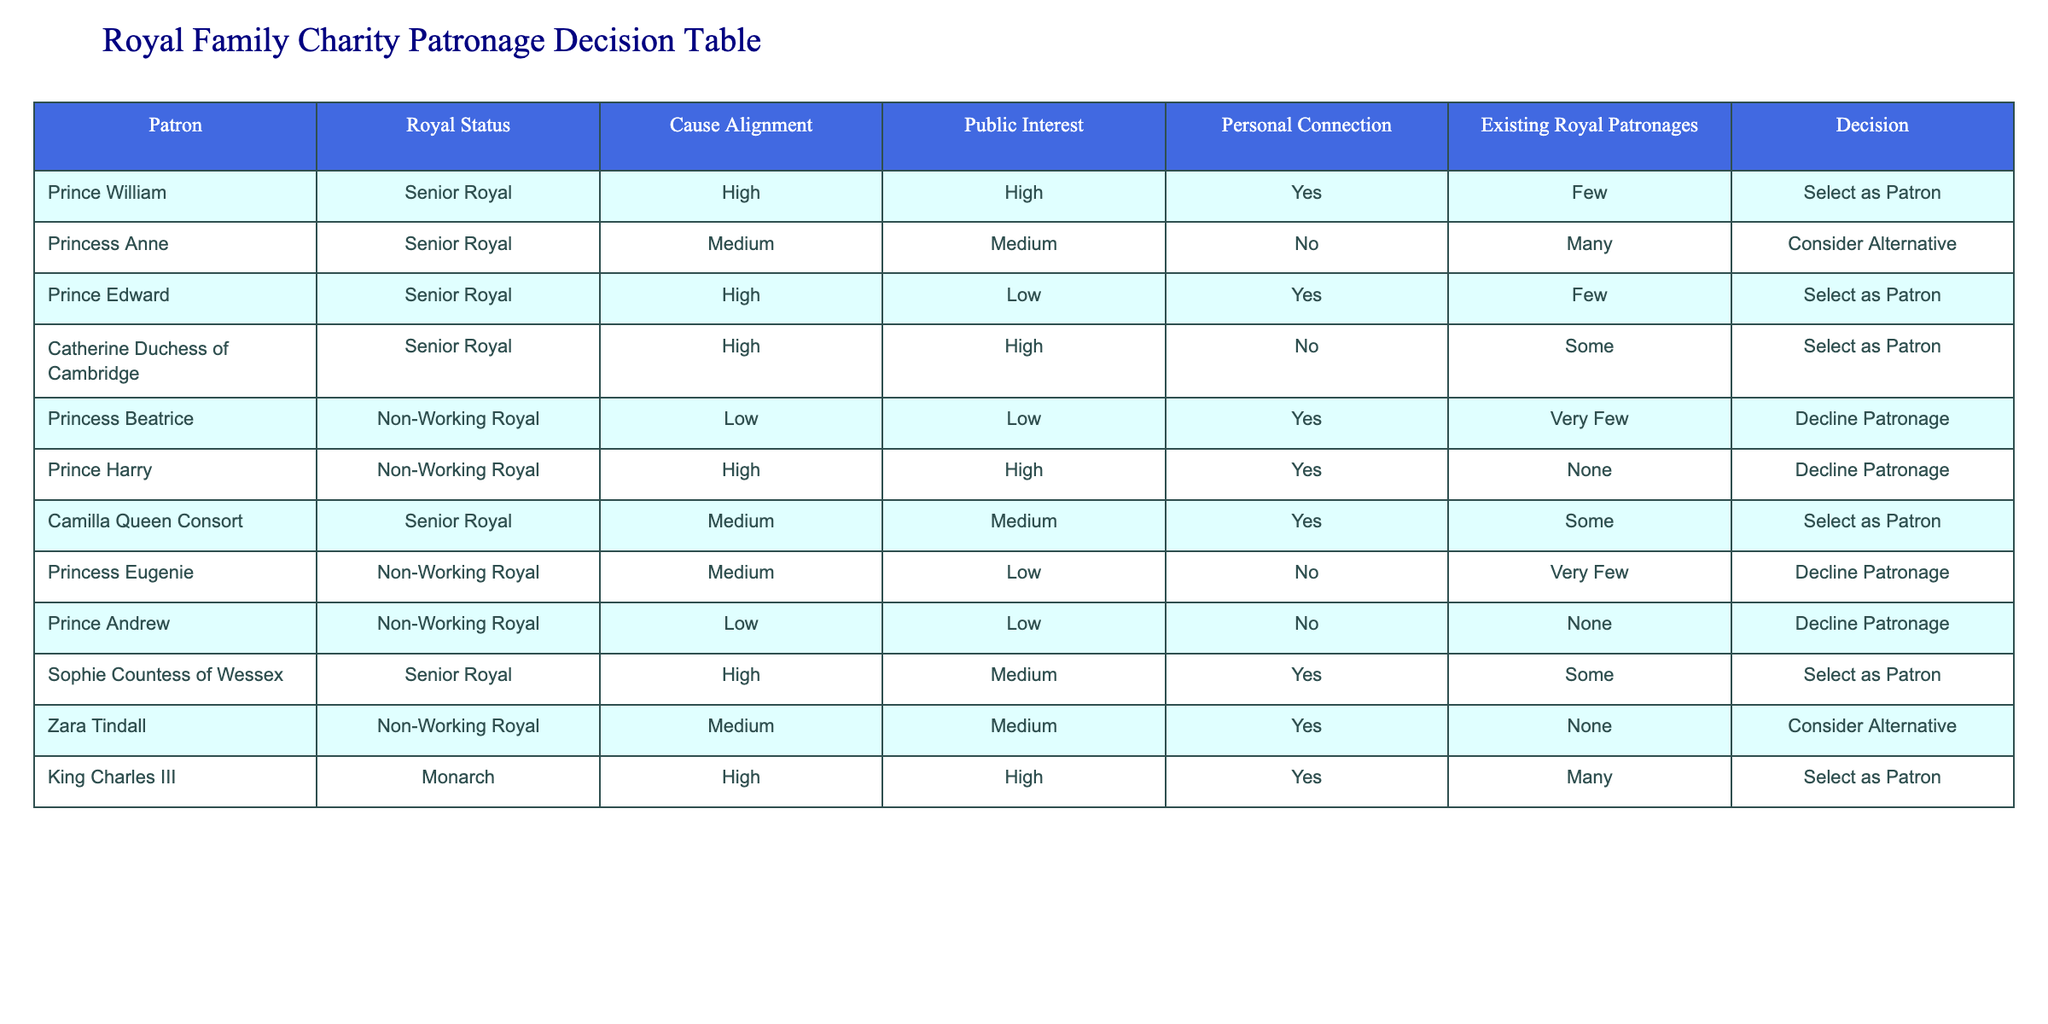What is the patronage decision for Prince William? The table clearly indicates that Prince William is selected as a patron, as mentioned in the "Decision" column next to his name.
Answer: Select as Patron How many royal family members are categorized as Non-Working Royals? By counting the entries under "Royal Status" in the table, we find that there are four Non-Working Royals: Princess Beatrice, Prince Harry, Princess Eugenie, and Prince Andrew.
Answer: Four Which royal family member has the most existing royal patronages? The table shows that Princess Anne has many existing royal patronages, more than any other listed members, indicated under the "Existing Royal Patronages" column.
Answer: Many Is there a royal family member who has a personal connection to their cause but is still declined patronage? Looking at the table, we see Princess Beatrice has a personal connection (Yes) to her cause but is declined patronage, as mentioned in the "Decision" column.
Answer: Yes What is the difference in the number of existing patronages between Prince Andrew and Prince Edward? Prince Andrew has no existing patronages, while Prince Edward has few. Calculating the difference: Few (considered as 1-2) minus None (0) gives a difference of at least 1. The exact count isn’t provided, but the difference is in favor of Prince Edward.
Answer: At least 1 Which senior royal has the highest cause alignment rating? According to the table, King Charles III and Prince Edward both have a high cause alignment rating listed, but only King Charles III is selected as a patron. So, in terms of alignment, both are equal, but King Charles is favored in decision making.
Answer: King Charles III Are any royals showing a high public interest but declining patronage? The examination of the table shows there are no royals with a high public interest who declined patronage; all high public interest members have been selected as patrons.
Answer: No Which royal has only "Consider Alternative" as their decision? From the table, Zara Tindall is the only one that has "Consider Alternative" in her decision.
Answer: Zara Tindall 